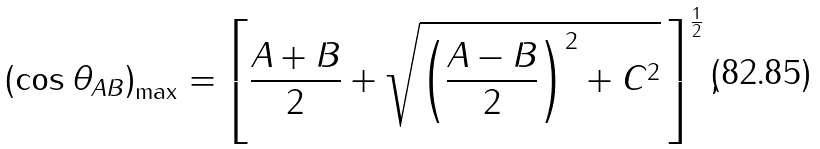<formula> <loc_0><loc_0><loc_500><loc_500>\left ( \cos \theta _ { A B } \right ) _ { \max } = \left [ \frac { A + B } { 2 } + \sqrt { \left ( \frac { A - B } { 2 } \right ) ^ { 2 } + C ^ { 2 } } \, \right ] ^ { \frac { 1 } { 2 } } ,</formula> 